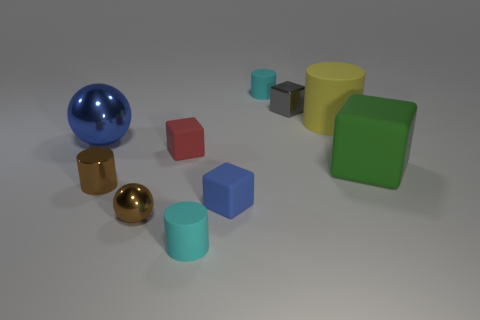What number of cubes are behind the red object and in front of the big matte cylinder?
Your response must be concise. 0. Are there more yellow cylinders that are on the right side of the shiny cylinder than cyan rubber blocks?
Your answer should be compact. Yes. How many red blocks have the same size as the brown metallic cylinder?
Provide a succinct answer. 1. There is a rubber block that is the same color as the big metallic sphere; what size is it?
Offer a terse response. Small. What number of small objects are either blue shiny cubes or gray metal objects?
Make the answer very short. 1. What number of big cyan shiny cubes are there?
Keep it short and to the point. 0. Is the number of tiny metal cylinders to the right of the yellow object the same as the number of metal spheres behind the blue metallic ball?
Provide a short and direct response. Yes. Are there any tiny cylinders on the right side of the small gray shiny object?
Make the answer very short. No. What color is the large thing that is in front of the red thing?
Ensure brevity in your answer.  Green. The sphere behind the brown metallic cylinder in front of the large blue shiny object is made of what material?
Keep it short and to the point. Metal. 